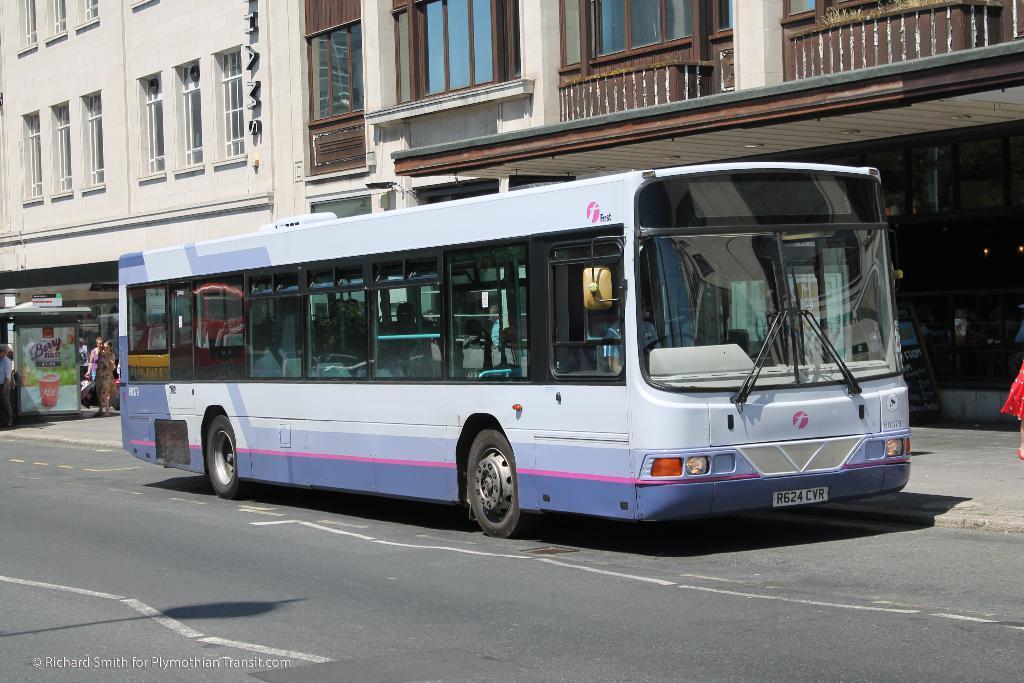Could you give a brief overview of what you see in this image? In this picture, we can see a few people, and a few in vehicle, and we can see the road, store, building with windows, glass doors, and fencing. 